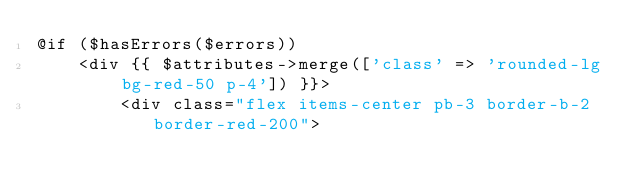Convert code to text. <code><loc_0><loc_0><loc_500><loc_500><_PHP_>@if ($hasErrors($errors))
    <div {{ $attributes->merge(['class' => 'rounded-lg bg-red-50 p-4']) }}>
        <div class="flex items-center pb-3 border-b-2 border-red-200"></code> 